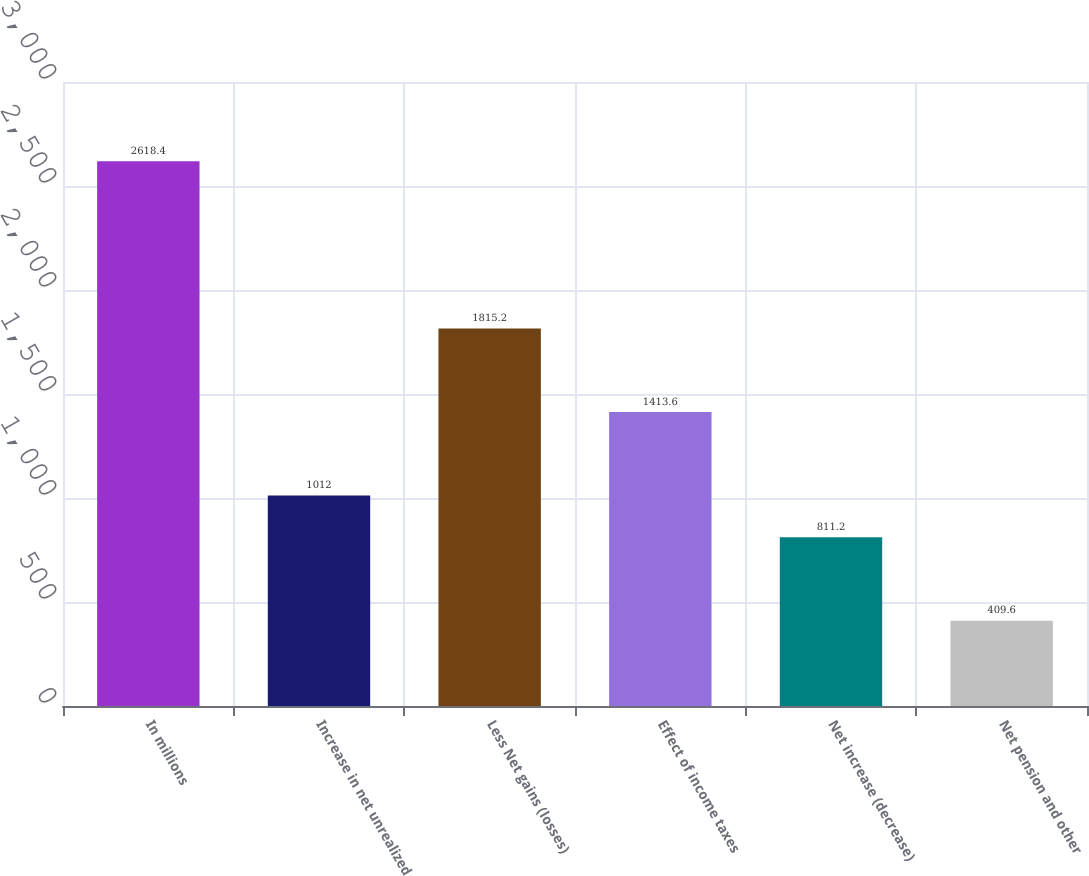Convert chart to OTSL. <chart><loc_0><loc_0><loc_500><loc_500><bar_chart><fcel>In millions<fcel>Increase in net unrealized<fcel>Less Net gains (losses)<fcel>Effect of income taxes<fcel>Net increase (decrease)<fcel>Net pension and other<nl><fcel>2618.4<fcel>1012<fcel>1815.2<fcel>1413.6<fcel>811.2<fcel>409.6<nl></chart> 